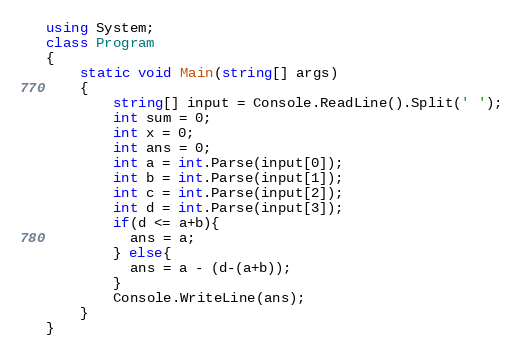<code> <loc_0><loc_0><loc_500><loc_500><_C#_>using System;
class Program
{
    static void Main(string[] args)
    {
        string[] input = Console.ReadLine().Split(' ');
      	int sum = 0;
      	int x = 0;
        int ans = 0;
        int a = int.Parse(input[0]);
        int b = int.Parse(input[1]);
        int c = int.Parse(input[2]);
        int d = int.Parse(input[3]);
        if(d <= a+b){
          ans = a;
        } else{
          ans = a - (d-(a+b));
        }
        Console.WriteLine(ans);
    }
}</code> 